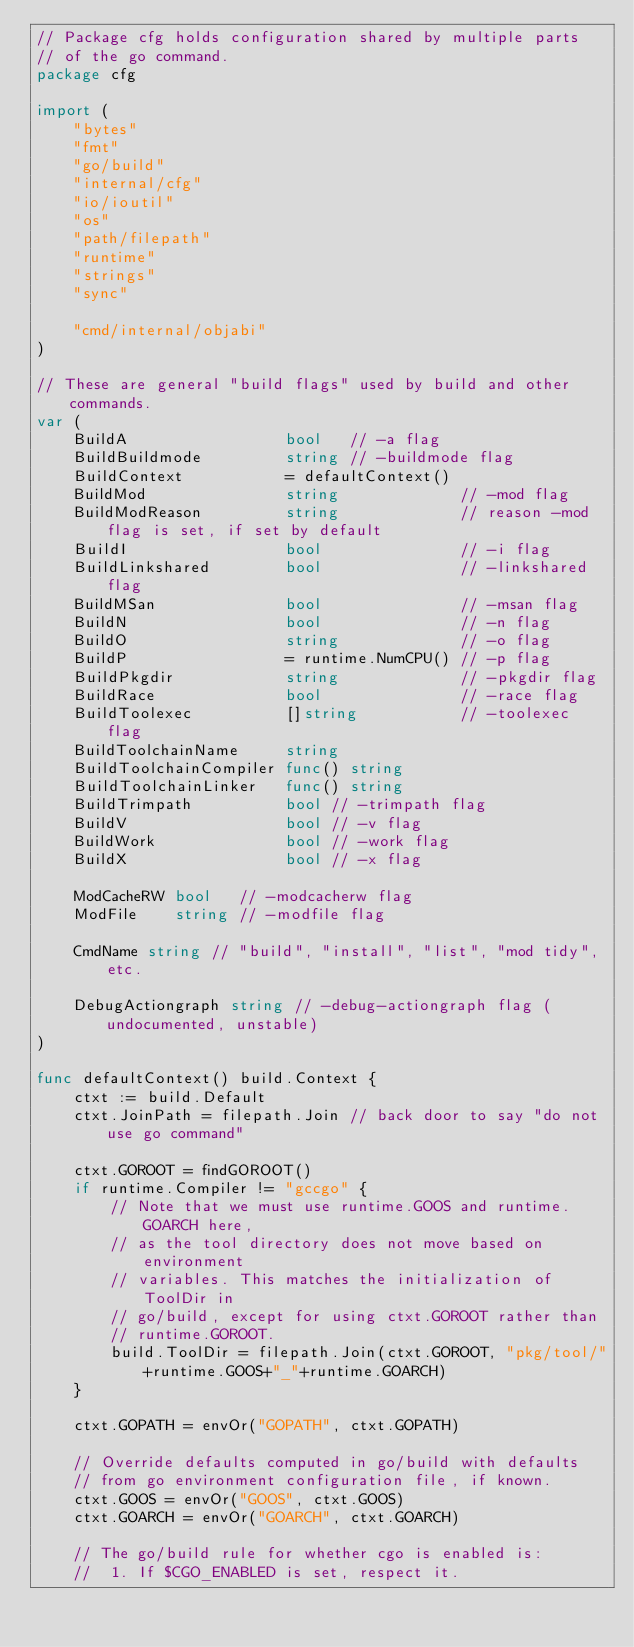Convert code to text. <code><loc_0><loc_0><loc_500><loc_500><_Go_>// Package cfg holds configuration shared by multiple parts
// of the go command.
package cfg

import (
	"bytes"
	"fmt"
	"go/build"
	"internal/cfg"
	"io/ioutil"
	"os"
	"path/filepath"
	"runtime"
	"strings"
	"sync"

	"cmd/internal/objabi"
)

// These are general "build flags" used by build and other commands.
var (
	BuildA                 bool   // -a flag
	BuildBuildmode         string // -buildmode flag
	BuildContext           = defaultContext()
	BuildMod               string             // -mod flag
	BuildModReason         string             // reason -mod flag is set, if set by default
	BuildI                 bool               // -i flag
	BuildLinkshared        bool               // -linkshared flag
	BuildMSan              bool               // -msan flag
	BuildN                 bool               // -n flag
	BuildO                 string             // -o flag
	BuildP                 = runtime.NumCPU() // -p flag
	BuildPkgdir            string             // -pkgdir flag
	BuildRace              bool               // -race flag
	BuildToolexec          []string           // -toolexec flag
	BuildToolchainName     string
	BuildToolchainCompiler func() string
	BuildToolchainLinker   func() string
	BuildTrimpath          bool // -trimpath flag
	BuildV                 bool // -v flag
	BuildWork              bool // -work flag
	BuildX                 bool // -x flag

	ModCacheRW bool   // -modcacherw flag
	ModFile    string // -modfile flag

	CmdName string // "build", "install", "list", "mod tidy", etc.

	DebugActiongraph string // -debug-actiongraph flag (undocumented, unstable)
)

func defaultContext() build.Context {
	ctxt := build.Default
	ctxt.JoinPath = filepath.Join // back door to say "do not use go command"

	ctxt.GOROOT = findGOROOT()
	if runtime.Compiler != "gccgo" {
		// Note that we must use runtime.GOOS and runtime.GOARCH here,
		// as the tool directory does not move based on environment
		// variables. This matches the initialization of ToolDir in
		// go/build, except for using ctxt.GOROOT rather than
		// runtime.GOROOT.
		build.ToolDir = filepath.Join(ctxt.GOROOT, "pkg/tool/"+runtime.GOOS+"_"+runtime.GOARCH)
	}

	ctxt.GOPATH = envOr("GOPATH", ctxt.GOPATH)

	// Override defaults computed in go/build with defaults
	// from go environment configuration file, if known.
	ctxt.GOOS = envOr("GOOS", ctxt.GOOS)
	ctxt.GOARCH = envOr("GOARCH", ctxt.GOARCH)

	// The go/build rule for whether cgo is enabled is:
	//	1. If $CGO_ENABLED is set, respect it.</code> 